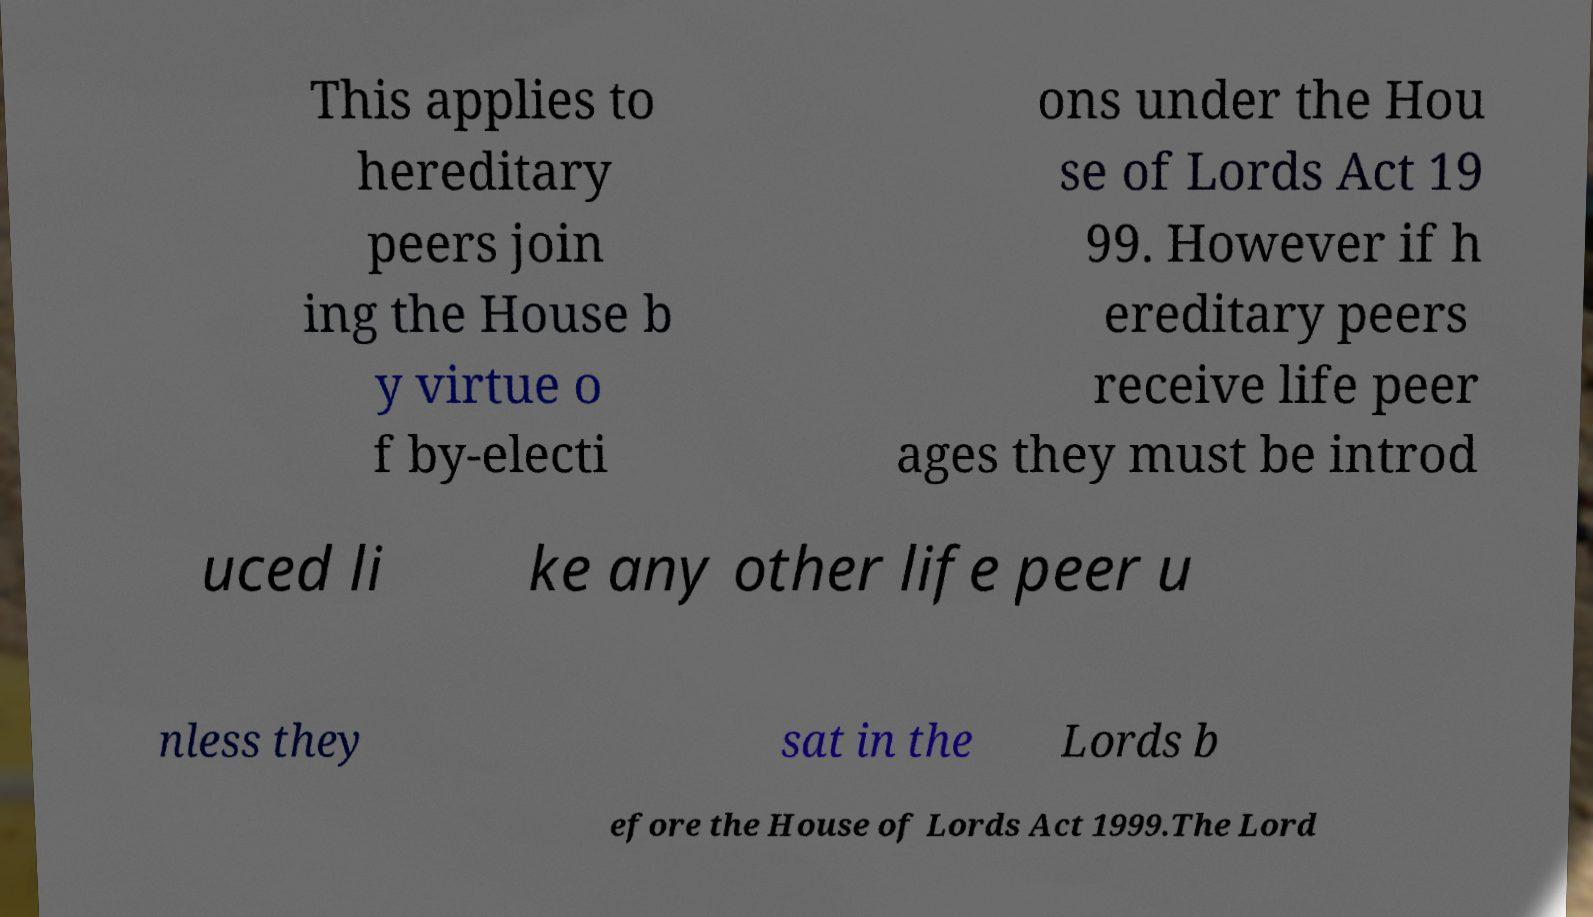Please identify and transcribe the text found in this image. This applies to hereditary peers join ing the House b y virtue o f by-electi ons under the Hou se of Lords Act 19 99. However if h ereditary peers receive life peer ages they must be introd uced li ke any other life peer u nless they sat in the Lords b efore the House of Lords Act 1999.The Lord 